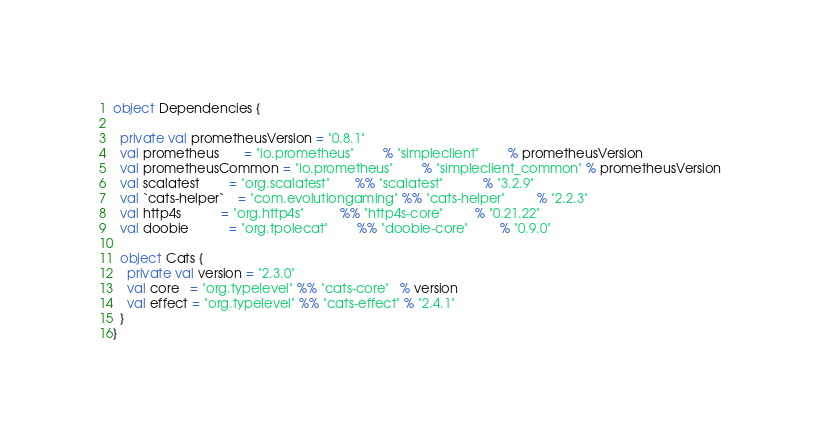Convert code to text. <code><loc_0><loc_0><loc_500><loc_500><_Scala_>object Dependencies {

  private val prometheusVersion = "0.8.1"
  val prometheus       = "io.prometheus"        % "simpleclient"        % prometheusVersion
  val prometheusCommon = "io.prometheus"        % "simpleclient_common" % prometheusVersion
  val scalatest        = "org.scalatest"       %% "scalatest"           % "3.2.9"
  val `cats-helper`    = "com.evolutiongaming" %% "cats-helper"         % "2.2.3"
  val http4s           = "org.http4s"          %% "http4s-core"         % "0.21.22"
  val doobie           = "org.tpolecat"        %% "doobie-core"         % "0.9.0"

  object Cats {
    private val version = "2.3.0"
    val core   = "org.typelevel" %% "cats-core"   % version
    val effect = "org.typelevel" %% "cats-effect" % "2.4.1"
  }
}
</code> 